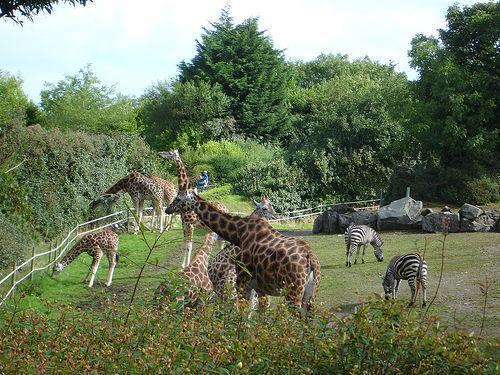How many zebras can be seen?
Give a very brief answer. 2. 